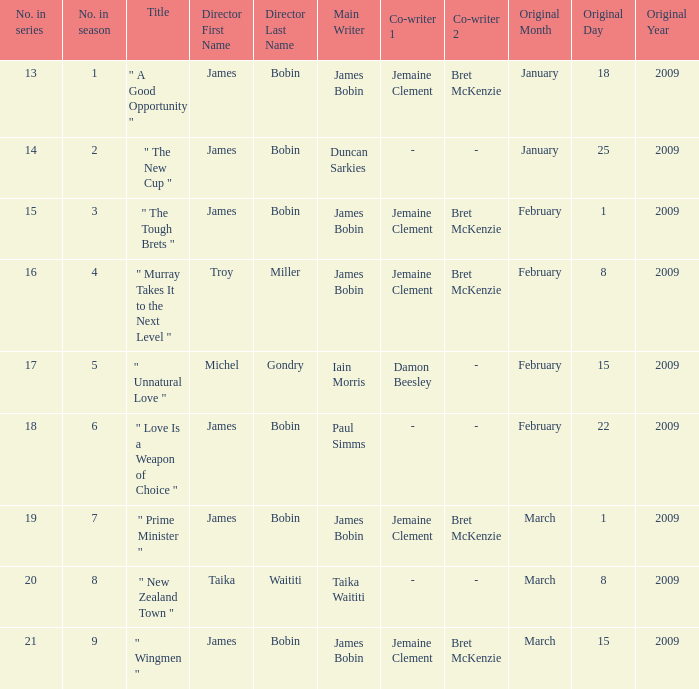What is the first airing date of the episode authored by iain morris & damon beesley? February15,2009. 